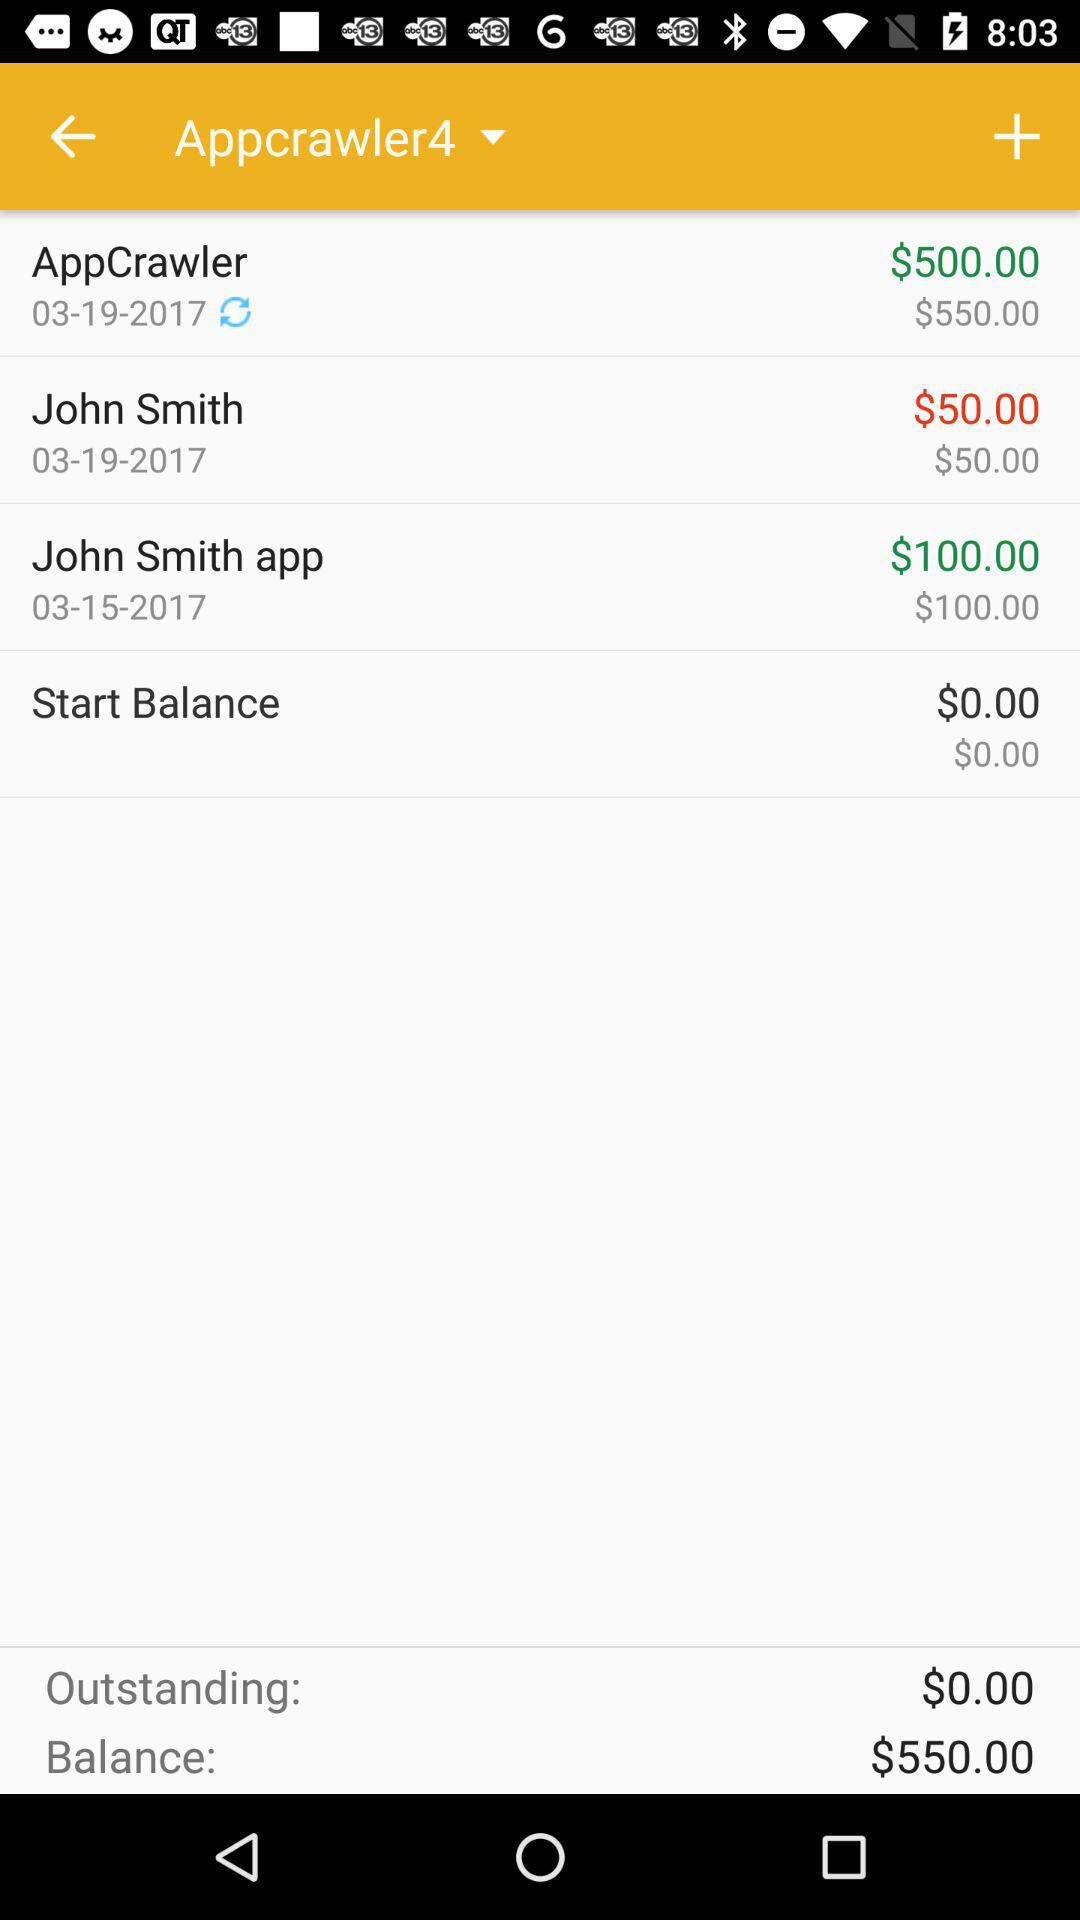What's the starting balance? The starting balance is $0.00. 